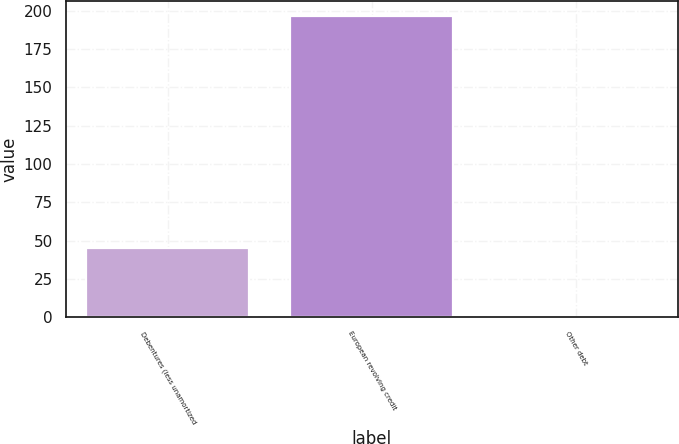<chart> <loc_0><loc_0><loc_500><loc_500><bar_chart><fcel>Debentures (less unamortized<fcel>European revolving credit<fcel>Other debt<nl><fcel>45.4<fcel>196.4<fcel>0.1<nl></chart> 